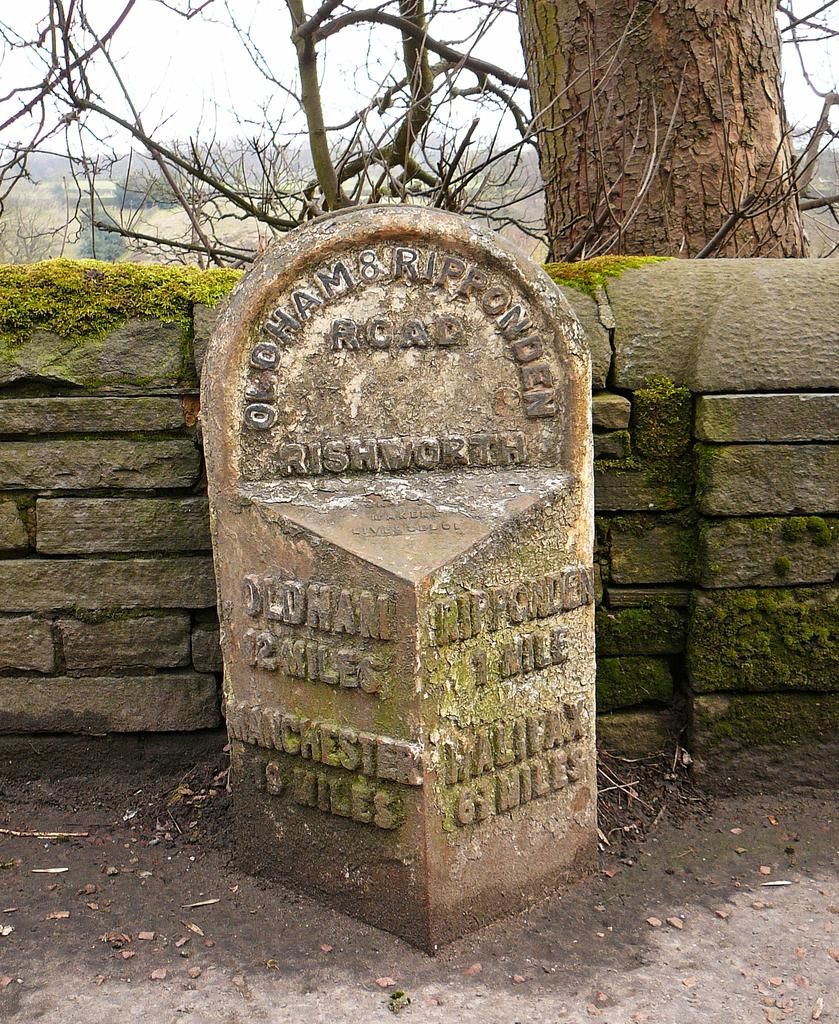What is the main object with text in the image? There is a laid stone with text on it in the image. What is the condition of the wall in the image? There is a wall with moss on it in the image. What type of vegetation can be seen in the image? There are trees visible in the image. What is visible in the background of the image? The sky is visible in the image. How many books are available in the library depicted in the image? There is no library depicted in the image, so it is not possible to determine the number of books available. 